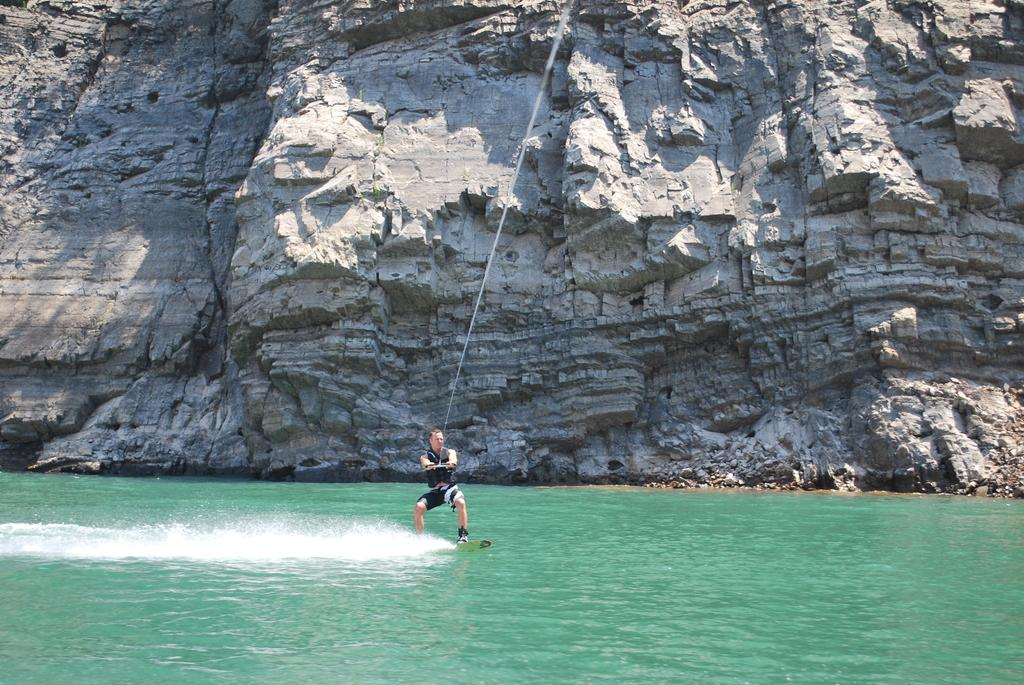What is the person in the image doing? The person is surfing on water. What tool is the person using to surf? The person is using a surfboard. Is the person holding anything while surfing? Yes, the person is holding a rope while surfing. What can be seen in the background of the image? There is a hill visible in the background of the image. What type of lace is the person wearing while surfing? There is no mention of lace in the image, and the person is not wearing any clothing that would involve lace. 